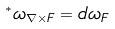<formula> <loc_0><loc_0><loc_500><loc_500>^ { * } \omega _ { \nabla \times F } = d \omega _ { F }</formula> 